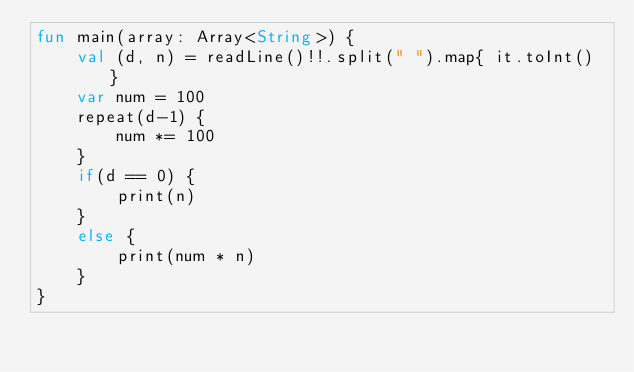Convert code to text. <code><loc_0><loc_0><loc_500><loc_500><_Kotlin_>fun main(array: Array<String>) {
    val (d, n) = readLine()!!.split(" ").map{ it.toInt() }
    var num = 100
    repeat(d-1) {
        num *= 100
    }
    if(d == 0) {
        print(n)
    }
    else {
        print(num * n)
    }
}</code> 